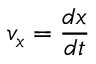Convert formula to latex. <formula><loc_0><loc_0><loc_500><loc_500>v _ { x } = { \frac { d x } { d t } }</formula> 